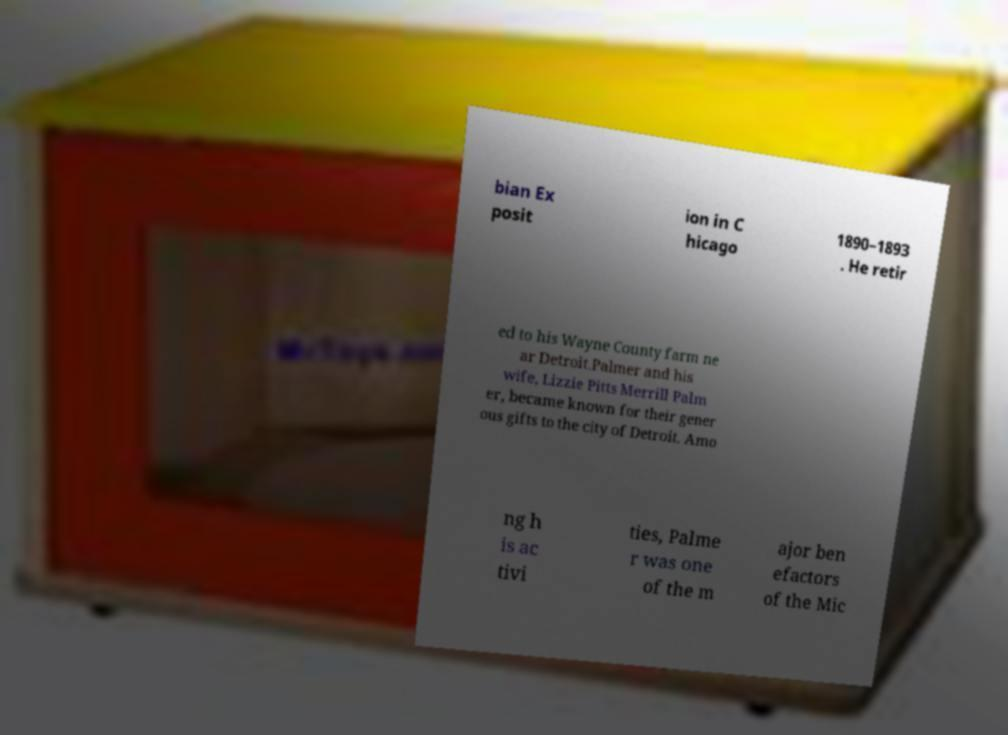What messages or text are displayed in this image? I need them in a readable, typed format. bian Ex posit ion in C hicago 1890–1893 . He retir ed to his Wayne County farm ne ar Detroit.Palmer and his wife, Lizzie Pitts Merrill Palm er, became known for their gener ous gifts to the city of Detroit. Amo ng h is ac tivi ties, Palme r was one of the m ajor ben efactors of the Mic 